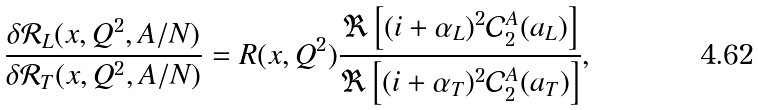Convert formula to latex. <formula><loc_0><loc_0><loc_500><loc_500>\frac { \delta \mathcal { R } _ { L } ( x , Q ^ { 2 } , { A / N } ) } { \delta \mathcal { R } _ { T } ( x , Q ^ { 2 } , { A / N } ) } = R ( x , Q ^ { 2 } ) \frac { \Re \left [ ( i + \alpha _ { L } ) ^ { 2 } \mathcal { C } _ { 2 } ^ { A } ( a _ { L } ) \right ] } { \Re \left [ ( i + \alpha _ { T } ) ^ { 2 } \mathcal { C } _ { 2 } ^ { A } ( a _ { T } ) \right ] } ,</formula> 